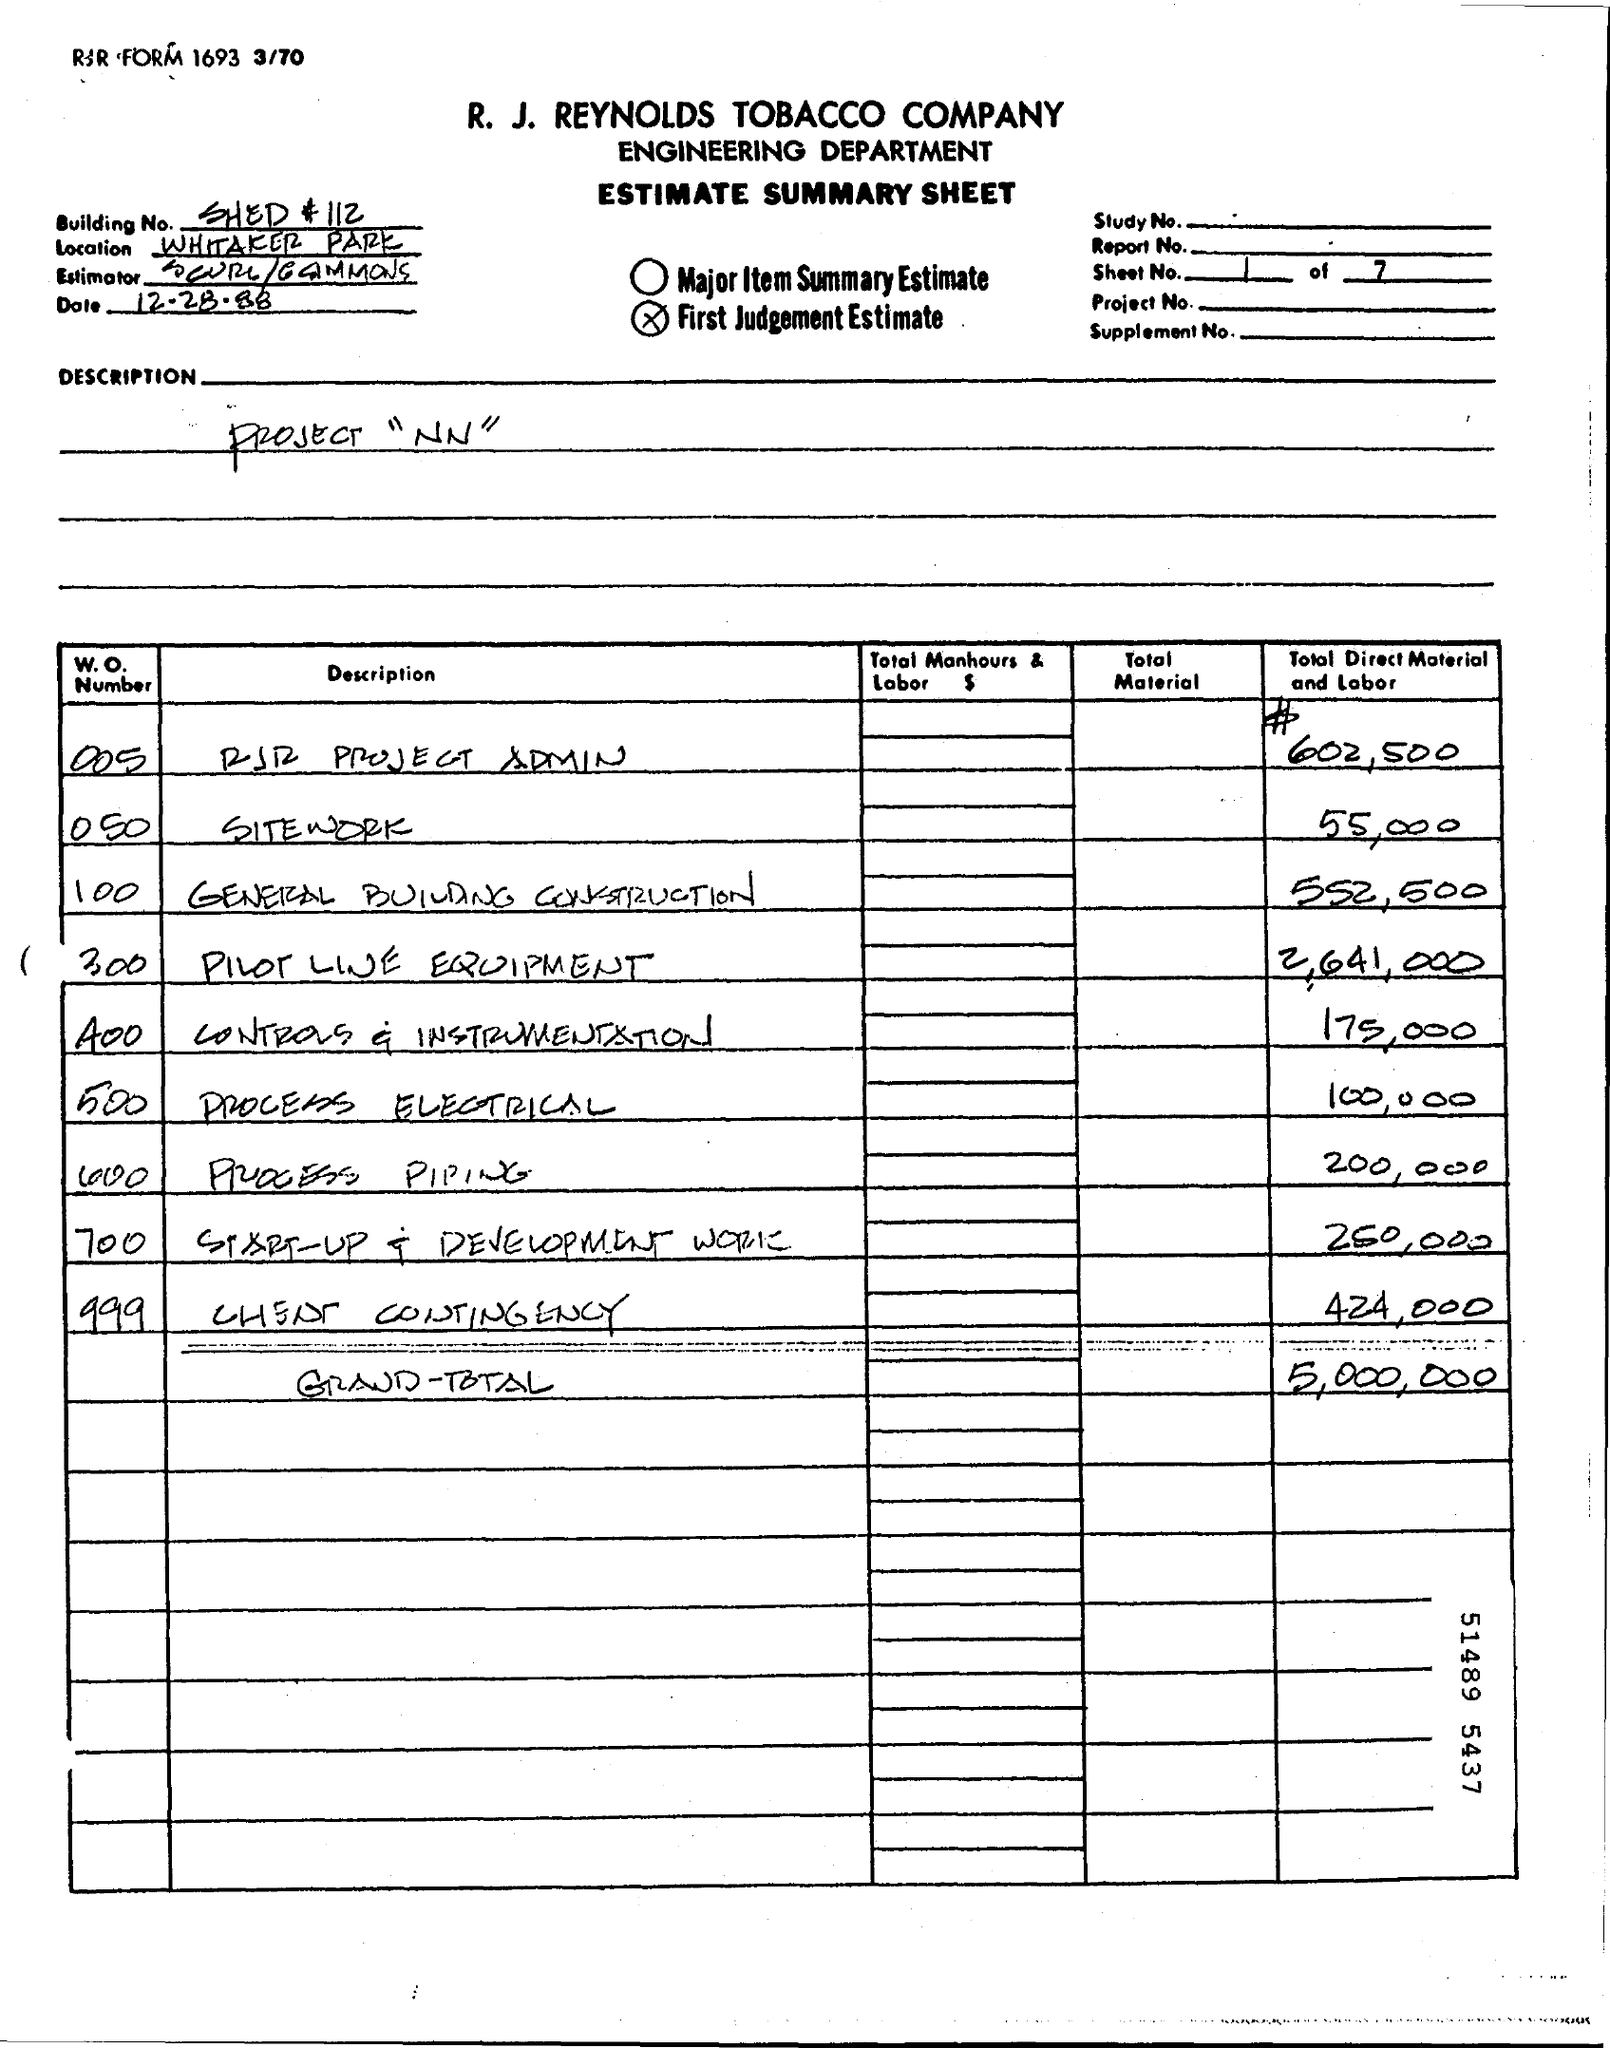Mention a couple of crucial points in this snapshot. The project name written on this sheet is "Project NN. 